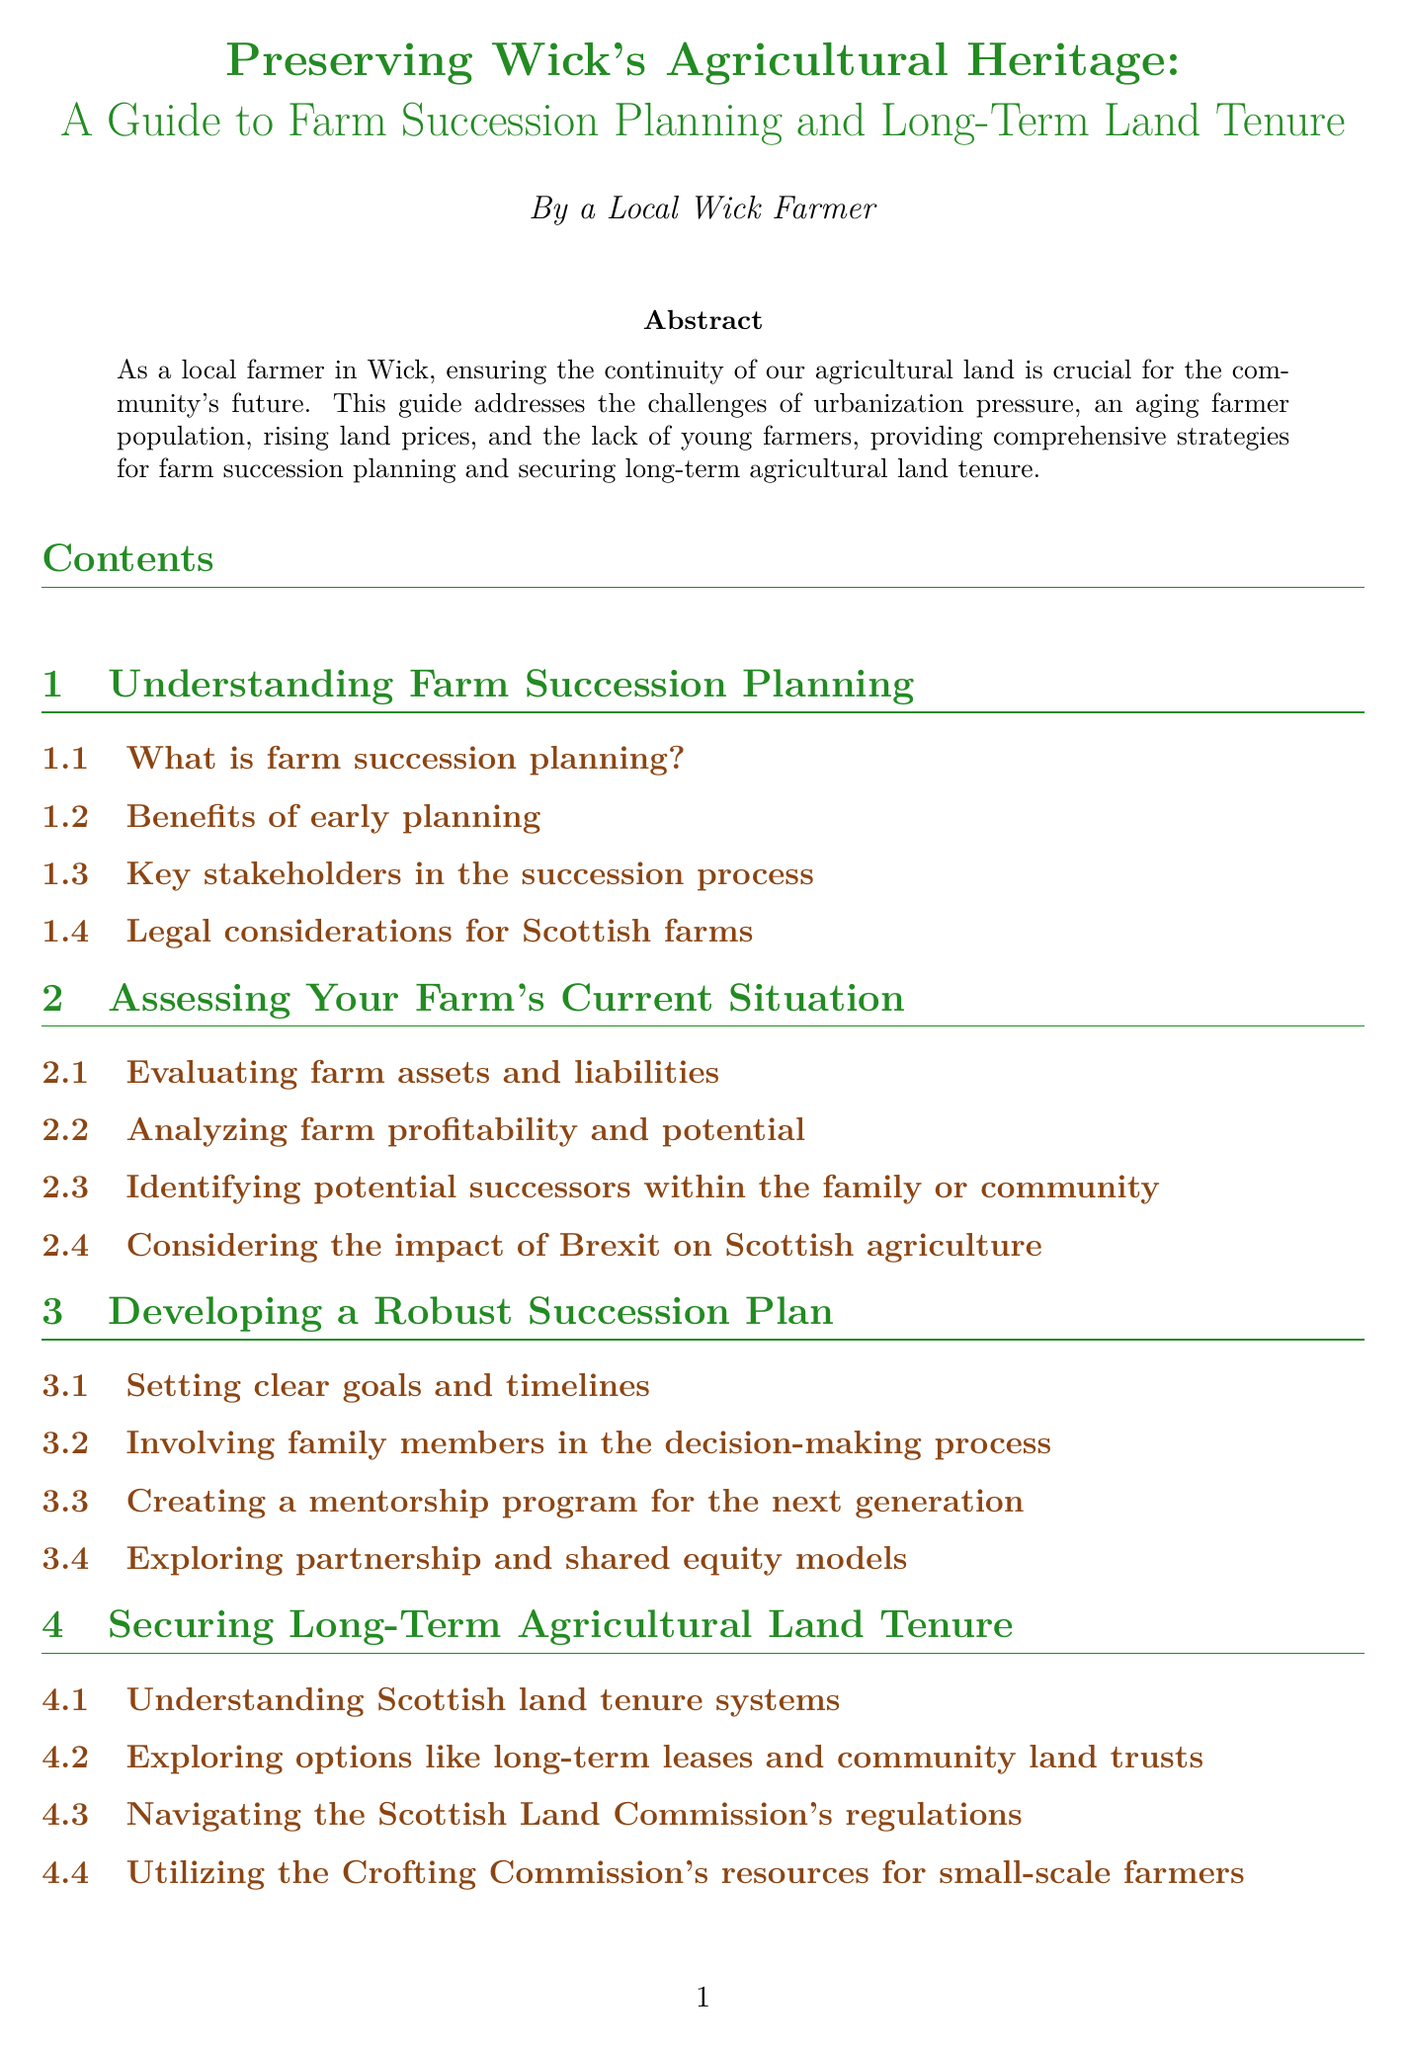What is the title of the manual? The title appears at the top of the document and is stated as "Preserving Wick's Agricultural Heritage: A Guide to Farm Succession Planning and Long-Term Land Tenure."
Answer: Preserving Wick's Agricultural Heritage: A Guide to Farm Succession Planning and Long-Term Land Tenure What is discussed in the chapter about financial planning? The chapter on financial planning covers various aspects including retirement needs, funding options, tax implications, and insurance considerations for farm succession.
Answer: Financial Planning for Farm Transition How many sections are in the "Developing a Robust Succession Plan" chapter? The document outlines four sections within the chapter on developing a robust succession plan, each addressing different planning strategies.
Answer: 4 What local initiative supports farmer mentorship? The document lists the Caithness Young Farmers' Club mentorship scheme as a local initiative focused on supporting young farmers in Wick.
Answer: Caithness Young Farmers' Club mentorship scheme What is one key challenge mentioned regarding local agriculture? Among the challenges listed, preserving prime agricultural land amid wind farm developments is highlighted as a significant concern for agricultural land preservation.
Answer: Preserving prime agricultural land in the face of wind farm developments Which commission's regulations are discussed in relation to land tenure? The document refers to the Scottish Land Commission as a relevant body for understanding land tenure systems and navigating regulations.
Answer: Scottish Land Commission 